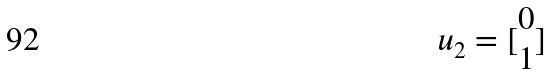<formula> <loc_0><loc_0><loc_500><loc_500>u _ { 2 } = [ \begin{matrix} 0 \\ 1 \end{matrix} ]</formula> 